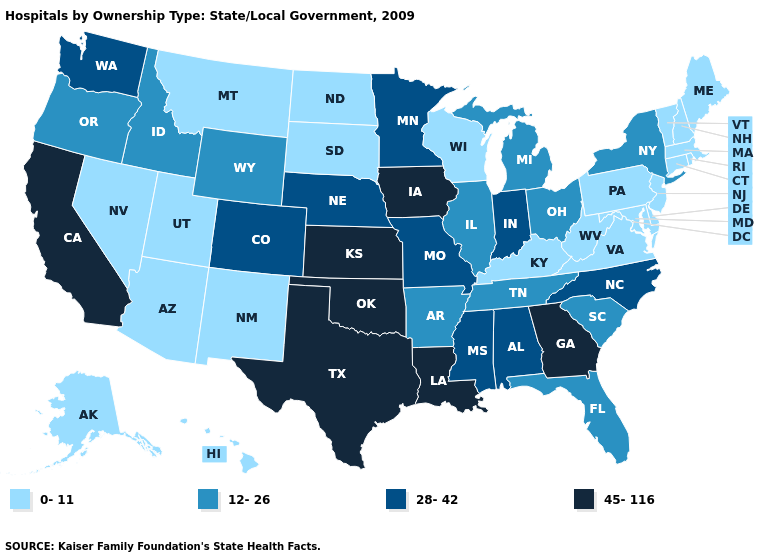What is the highest value in the Northeast ?
Be succinct. 12-26. Is the legend a continuous bar?
Short answer required. No. Which states have the lowest value in the USA?
Keep it brief. Alaska, Arizona, Connecticut, Delaware, Hawaii, Kentucky, Maine, Maryland, Massachusetts, Montana, Nevada, New Hampshire, New Jersey, New Mexico, North Dakota, Pennsylvania, Rhode Island, South Dakota, Utah, Vermont, Virginia, West Virginia, Wisconsin. Which states have the lowest value in the USA?
Answer briefly. Alaska, Arizona, Connecticut, Delaware, Hawaii, Kentucky, Maine, Maryland, Massachusetts, Montana, Nevada, New Hampshire, New Jersey, New Mexico, North Dakota, Pennsylvania, Rhode Island, South Dakota, Utah, Vermont, Virginia, West Virginia, Wisconsin. Does the map have missing data?
Give a very brief answer. No. Among the states that border Alabama , which have the highest value?
Concise answer only. Georgia. Does Virginia have the lowest value in the USA?
Quick response, please. Yes. Does Illinois have the highest value in the MidWest?
Be succinct. No. Which states have the lowest value in the USA?
Short answer required. Alaska, Arizona, Connecticut, Delaware, Hawaii, Kentucky, Maine, Maryland, Massachusetts, Montana, Nevada, New Hampshire, New Jersey, New Mexico, North Dakota, Pennsylvania, Rhode Island, South Dakota, Utah, Vermont, Virginia, West Virginia, Wisconsin. Name the states that have a value in the range 45-116?
Quick response, please. California, Georgia, Iowa, Kansas, Louisiana, Oklahoma, Texas. Does North Dakota have the lowest value in the USA?
Short answer required. Yes. What is the highest value in the USA?
Short answer required. 45-116. What is the highest value in states that border Georgia?
Give a very brief answer. 28-42. What is the highest value in the South ?
Answer briefly. 45-116. Which states hav the highest value in the South?
Quick response, please. Georgia, Louisiana, Oklahoma, Texas. 